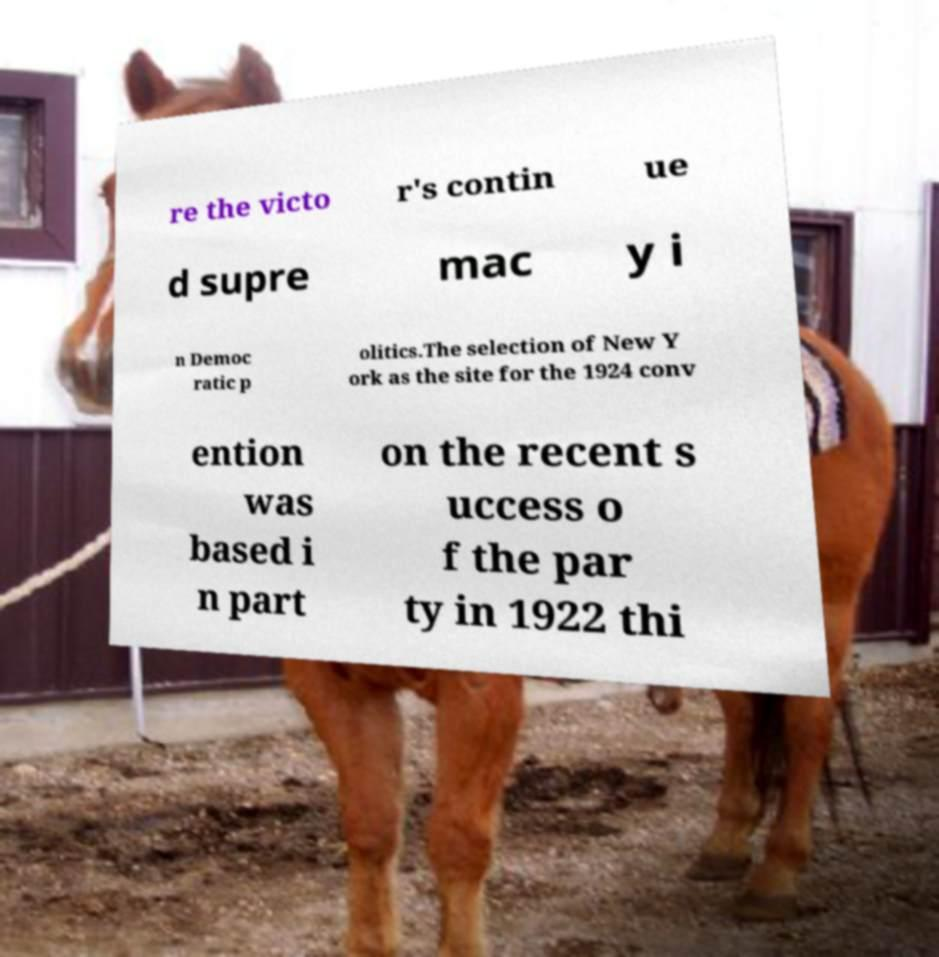Could you extract and type out the text from this image? re the victo r's contin ue d supre mac y i n Democ ratic p olitics.The selection of New Y ork as the site for the 1924 conv ention was based i n part on the recent s uccess o f the par ty in 1922 thi 